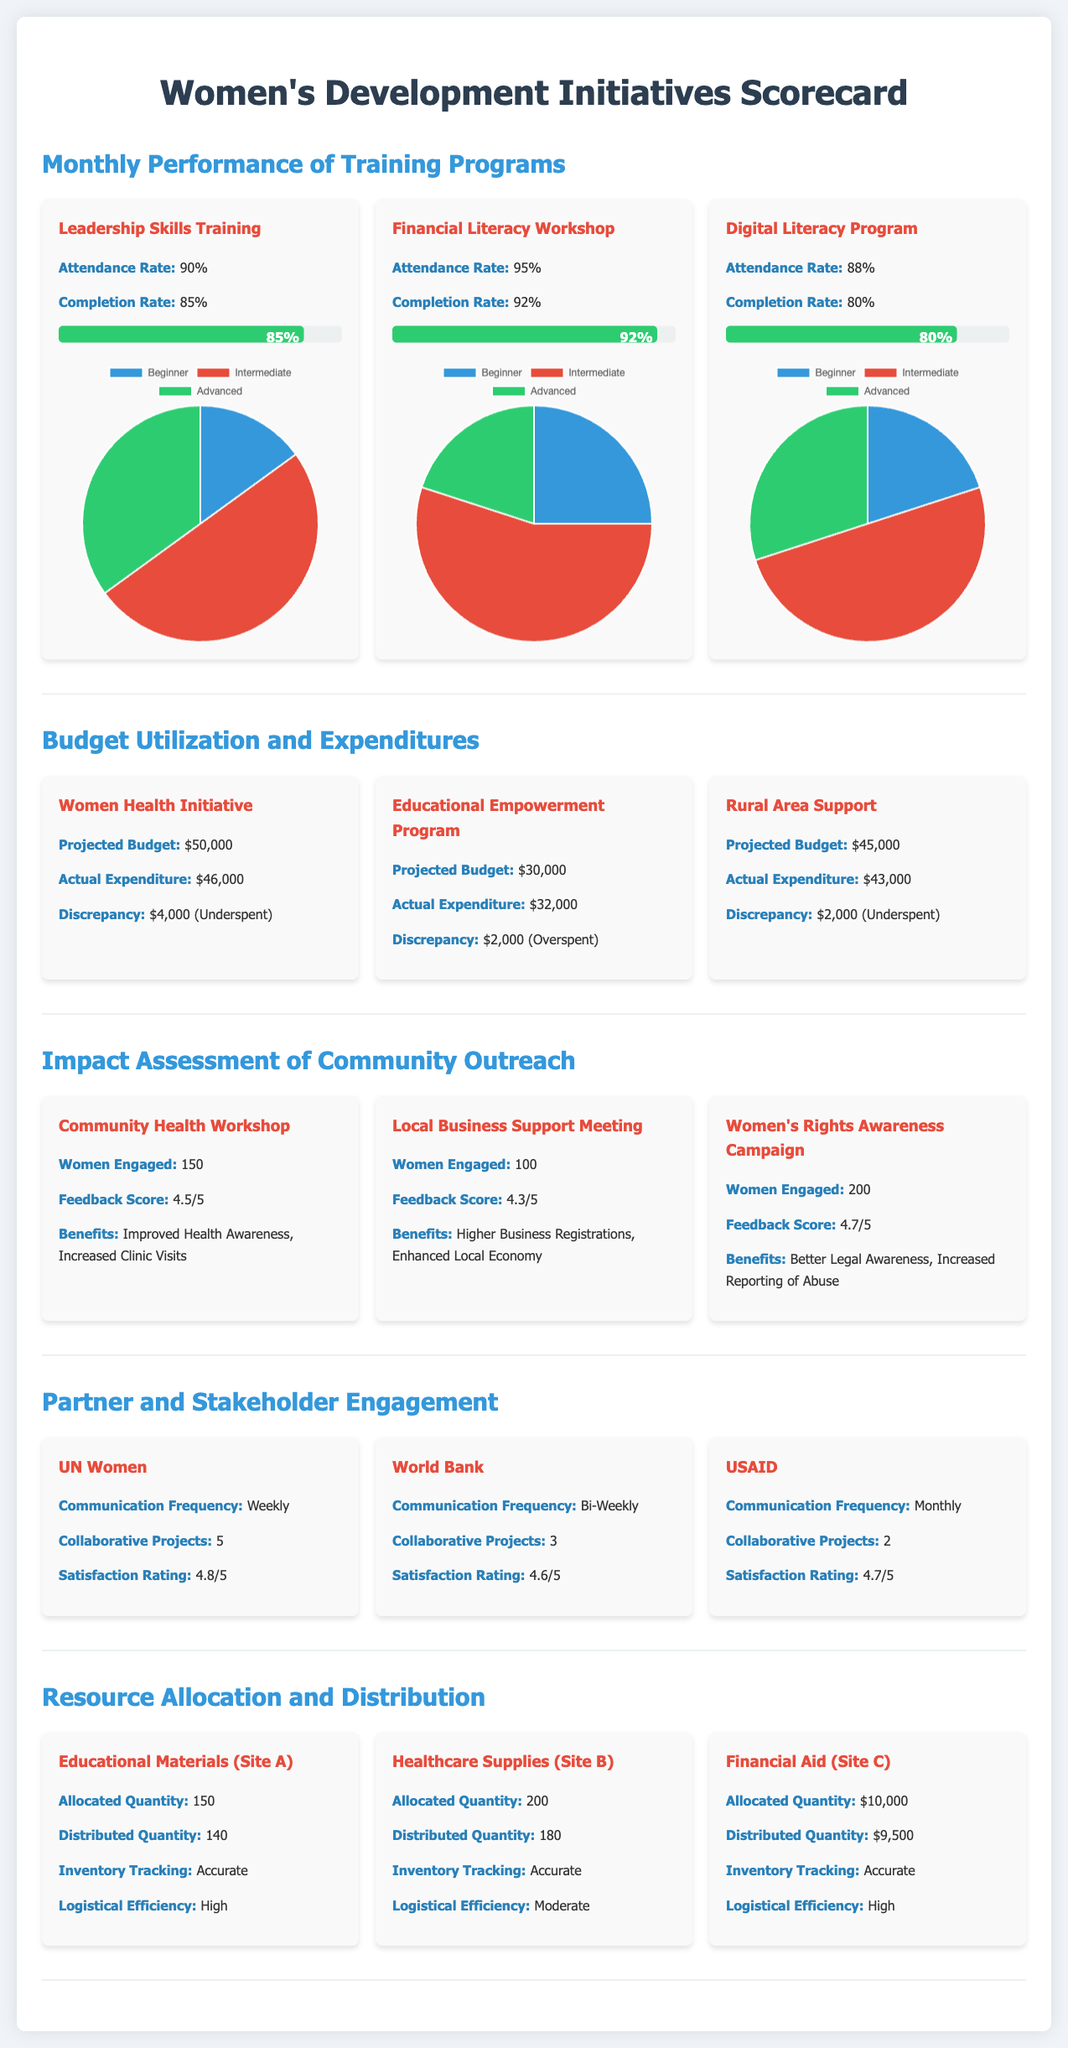What is the attendance rate for the Financial Literacy Workshop? The attendance rate for the Financial Literacy Workshop is noted in the scorecard as 95%.
Answer: 95% What is the actual expenditure for the Women Health Initiative? The actual expenditure for the Women Health Initiative is clearly stated as $46,000 in the budget utilization section.
Answer: $46,000 How many women were engaged in the Women's Rights Awareness Campaign? The scorecard indicates that 200 women were engaged in the Women's Rights Awareness Campaign.
Answer: 200 What is the satisfaction rating from the UN Women engagement? The satisfaction rating from UN Women is listed as 4.8 out of 5 in the partner and stakeholder engagement section.
Answer: 4.8/5 What discrepancy is highlighted for the Educational Empowerment Program? The scorecard notes a discrepancy of $2,000 (Overspent) for the Educational Empowerment Program in the budget section.
Answer: $2,000 (Overspent) What is the logistical efficiency for Healthcare Supplies (Site B)? The scorecard defines the logistical efficiency for Healthcare Supplies (Site B) as Moderate.
Answer: Moderate What is the projected budget for the Rural Area Support project? The projected budget for the Rural Area Support project is stated as $45,000 in the budget utilization section.
Answer: $45,000 What percentage is the completion rate for the Digital Literacy Program? The completion rate for the Digital Literacy Program is mentioned as 80% in the training programs section.
Answer: 80% How many collaborative projects has USAID completed? The scorecard indicates that USAID has completed 2 collaborative projects in the partner engagement section.
Answer: 2 